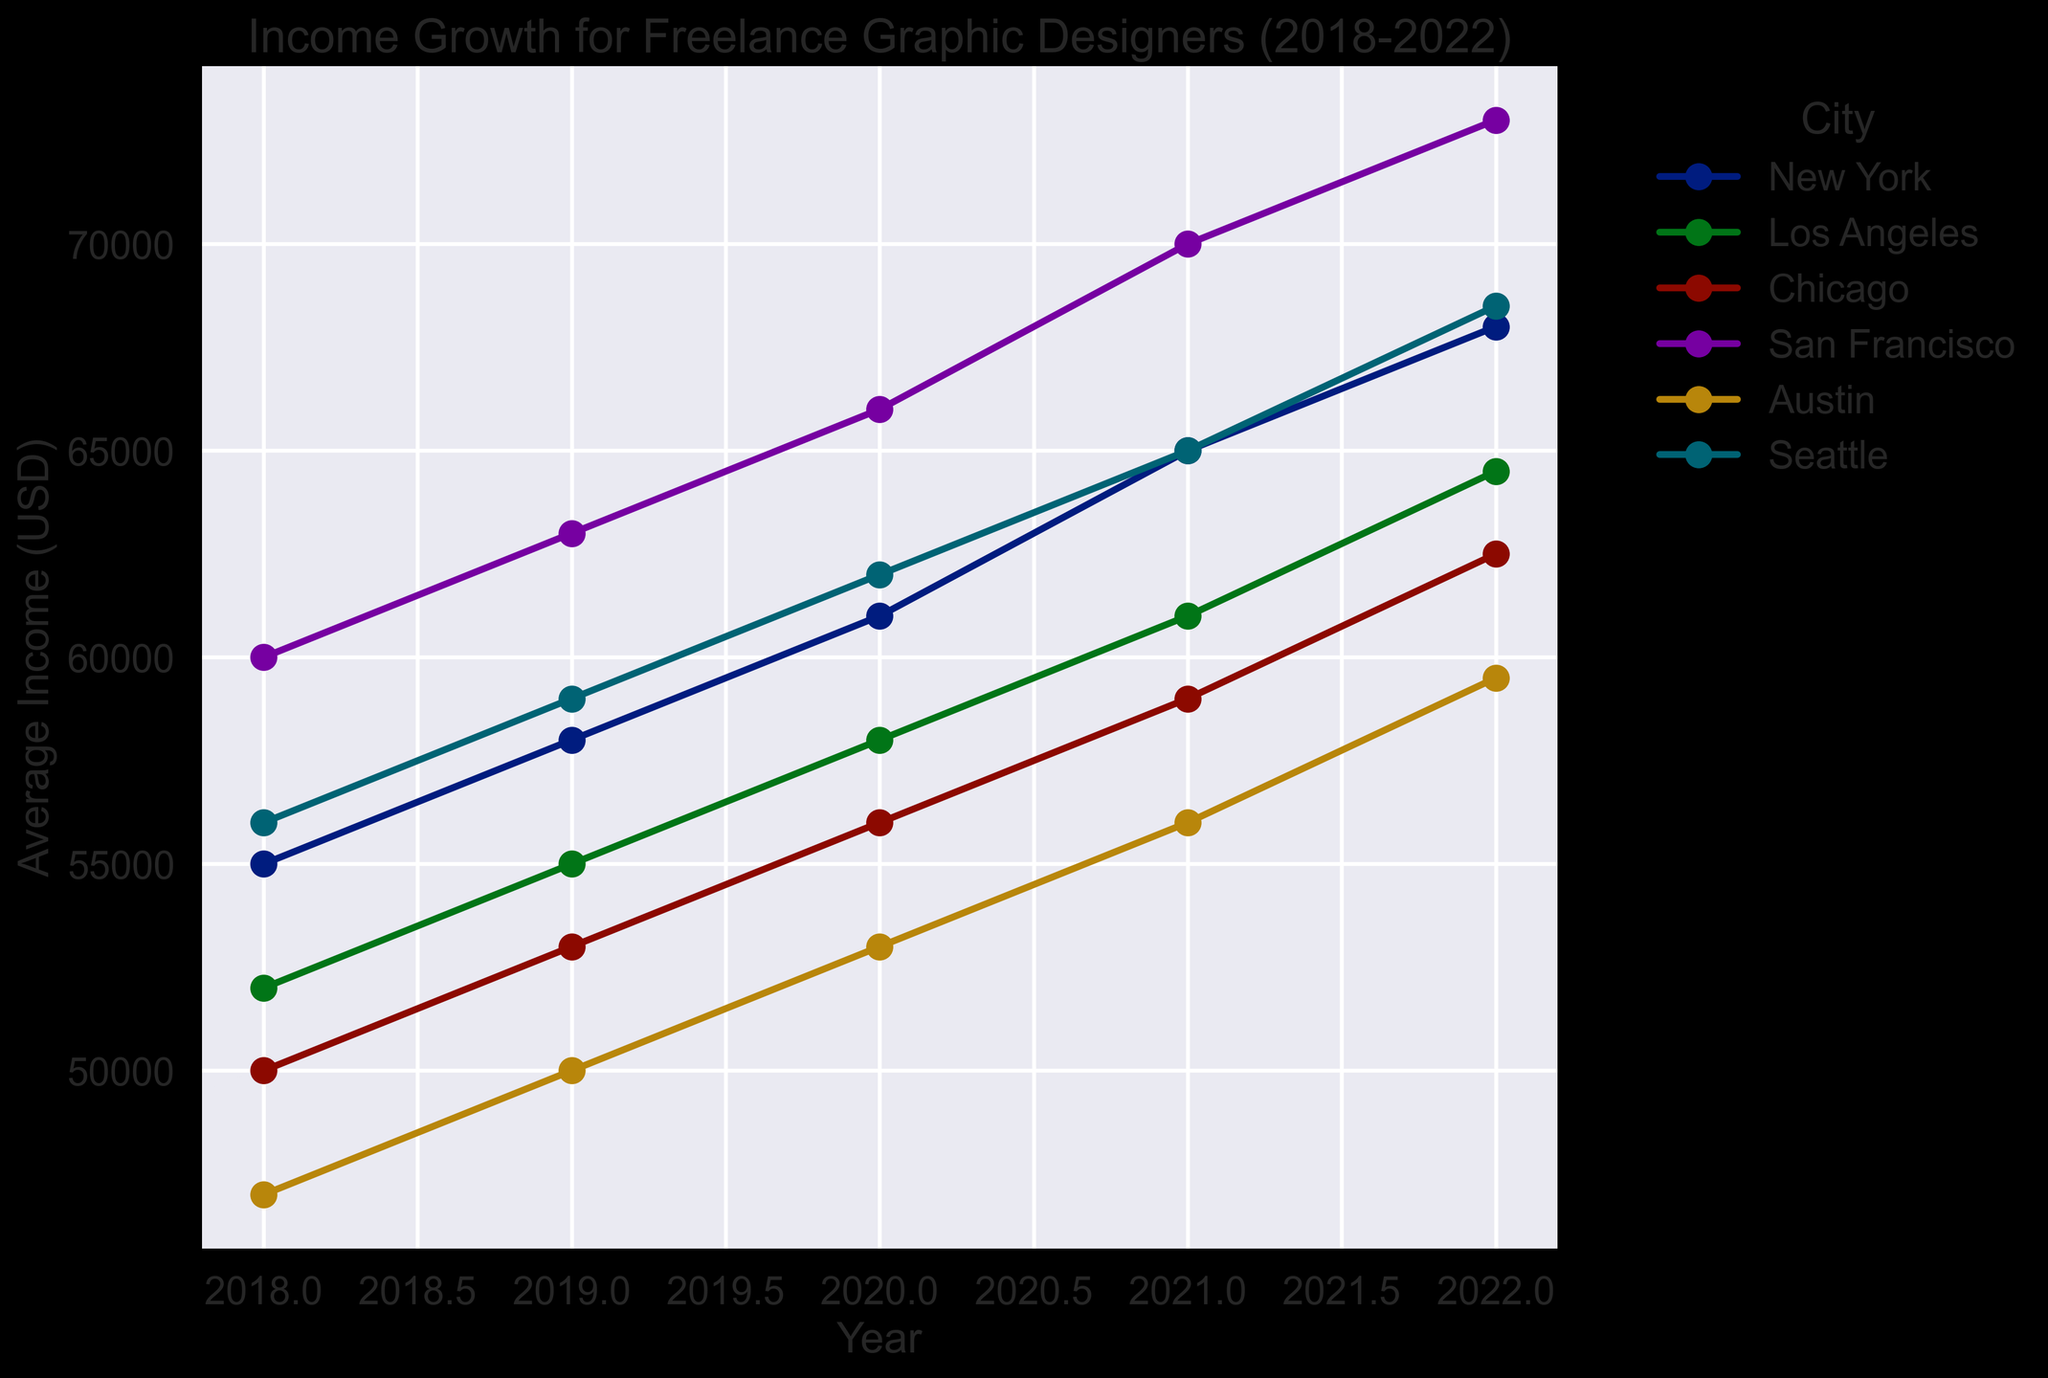Which city has the highest average income for freelance graphic designers in 2022? To determine the city with the highest average income in 2022, look at the endpoints of the lines in 2022 on the x-axis and find the highest point among them.
Answer: San Francisco What is the difference in average income between Chicago and Austin in 2021? Identify the average income for Chicago and Austin in 2021 from the y-axis. For Chicago, it's $59,000, and for Austin, it's $56,000. The difference is $59,000 - $56,000.
Answer: $3,000 Between 2018 and 2022, which city showed the largest growth in average income for freelance graphic designers? Calculate the income growth for each city by subtracting the 2018 average income from the 2022 average income and identify the highest one.
Answer: San Francisco What is the average income for freelance graphic designers in New York over the given period (2018-2022)? Sum the average incomes for New York from each year and divide by the number of years: (55000 + 58000 + 61000 + 65000 + 68000) / 5.
Answer: $61,800 Which city has shown a steady increase in average income without any plateau or dip over the years? Look at the trend lines for each city and identify if any city has a continuous upward trend without plateauing or decreasing at any point.
Answer: All cities How does the 2020 income for Los Angeles compare to Seattle? Identify the points for 2020 for both Los Angeles and Seattle. Look at the y-axis values: Los Angeles is $58,000, and Seattle is $62,000.
Answer: Seattle is $4,000 higher In which year did Austin's average income show the largest increase compared to the previous year? Observe the points for Austin and calculate the yearly income increases. Compare them to find the largest one.
Answer: 2021 What is the combined average income of freelance graphic designers in New York and Los Angeles in 2022? Add the average incomes for New York ($68,000) and Los Angeles ($64,500) for 2022.
Answer: $132,500 Which city's trend line is steepest, indicating the fastest growth rate, and in which period is this visible? Look at the slopes of each city's trend line and identify the city with the steepest slope and the specific period where it is most visible.
Answer: San Francisco, 2019-2021 